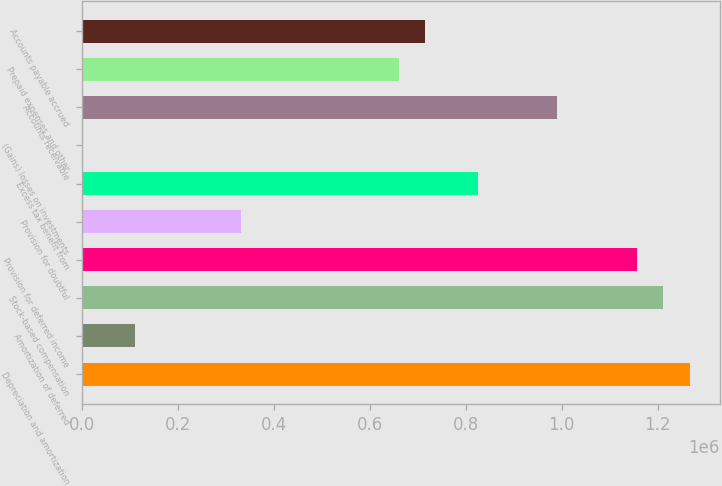Convert chart to OTSL. <chart><loc_0><loc_0><loc_500><loc_500><bar_chart><fcel>Depreciation and amortization<fcel>Amortization of deferred<fcel>Stock-based compensation<fcel>Provision for deferred income<fcel>Provision for doubtful<fcel>Excess tax benefit from<fcel>(Gains) losses on investments<fcel>Accounts receivable<fcel>Prepaid expenses and other<fcel>Accounts payable accrued<nl><fcel>1.26638e+06<fcel>110141<fcel>1.21132e+06<fcel>1.15626e+06<fcel>330378<fcel>825910<fcel>23<fcel>991087<fcel>660732<fcel>715791<nl></chart> 